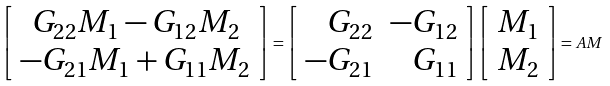Convert formula to latex. <formula><loc_0><loc_0><loc_500><loc_500>\left [ \begin{array} { c } G _ { 2 2 } M _ { 1 } - G _ { 1 2 } M _ { 2 } \\ - G _ { 2 1 } M _ { 1 } + G _ { 1 1 } M _ { 2 } \end{array} \right ] = \left [ \begin{array} { r r } G _ { 2 2 } & - G _ { 1 2 } \\ - G _ { 2 1 } & G _ { 1 1 } \end{array} \right ] \left [ \begin{array} { c } M _ { 1 } \\ M _ { 2 } \end{array} \right ] = A M</formula> 